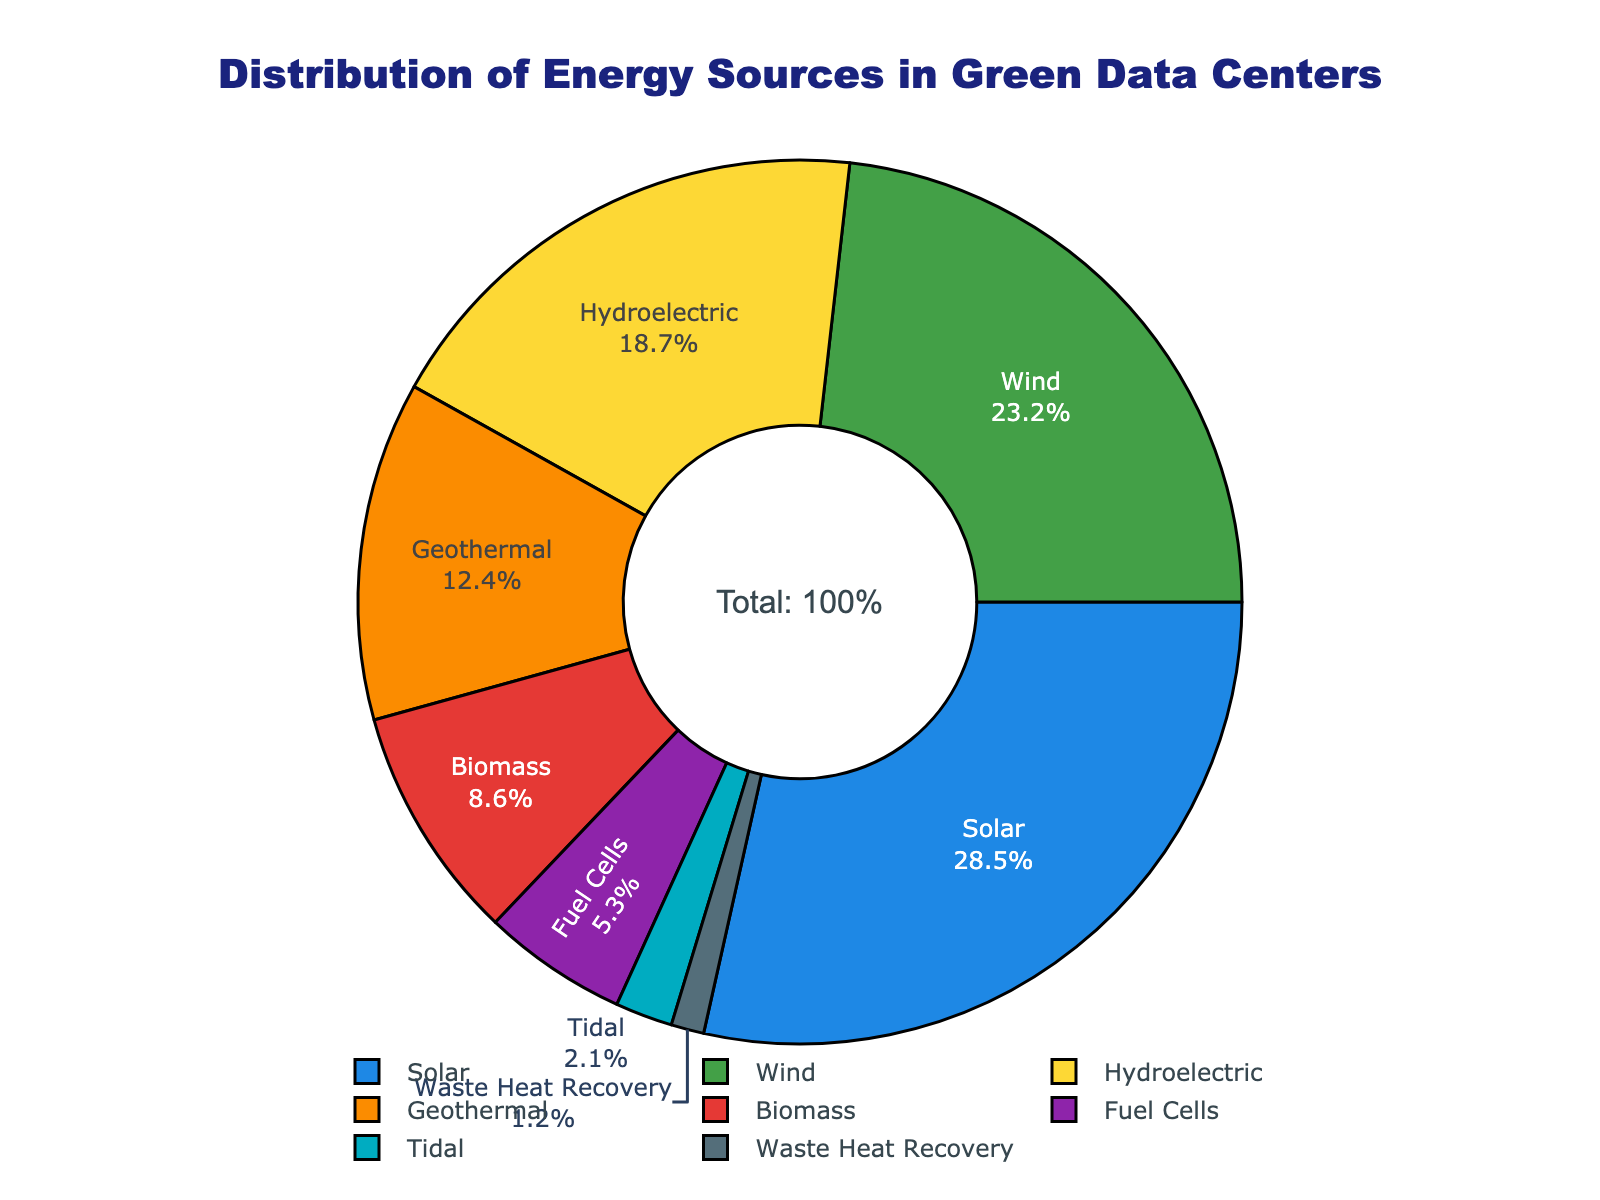What percentage of green data center energy comes from solar? The pie chart shows that the solar energy source contributes 28.5% to green data centers.
Answer: 28.5% Which energy source has the least contribution? The figure indicates that Waste Heat Recovery has the smallest slice, signifying its 1.2% contribution.
Answer: Waste Heat Recovery Is the contribution of wind energy greater than that of hydroelectric energy? The chart shows wind energy at 23.2% and hydroelectric at 18.7%.
Answer: Yes Compute the combined percentage of biomass, fuel cells, and tidal energy. Add the percentages of Biomass (8.6%), Fuel Cells (5.3%), and Tidal (2.1%). The total is 8.6 + 5.3 + 2.1 = 16.0%.
Answer: 16.0% Which energy source forms the highest percentage in the distribution? By looking at the slices, solar energy has the highest percentage at 28.5%.
Answer: Solar What is the color associated with hydroelectric energy in the pie chart? The color directly associated with hydroelectric energy is yellow.
Answer: Yellow Calculate the difference in percentage between the second largest and smallest energy sources. The second-largest is wind energy at 23.2%, and the smallest is Waste Heat Recovery at 1.2%. The difference is 23.2 - 1.2 = 22.0%.
Answer: 22.0% Are geothermal and biomass energy combined greater than solar energy? Combine Geothermal (12.4%) and Biomass (8.6%) to get 12.4 + 8.6 = 21.0%. Since Solar is 28.5%, the combined value is not greater.
Answer: No How much more significant is solar energy compared to fuel cells? Subtract the percentage of Fuel Cells (5.3%) from Solar (28.5%): 28.5 - 5.3 = 23.2%.
Answer: 23.2% What is the visual difference between the slices representing wind and tidal energy in the pie chart? Visually, the slice for wind energy is much larger than the small slice for tidal energy.
Answer: Wind slice is much larger 